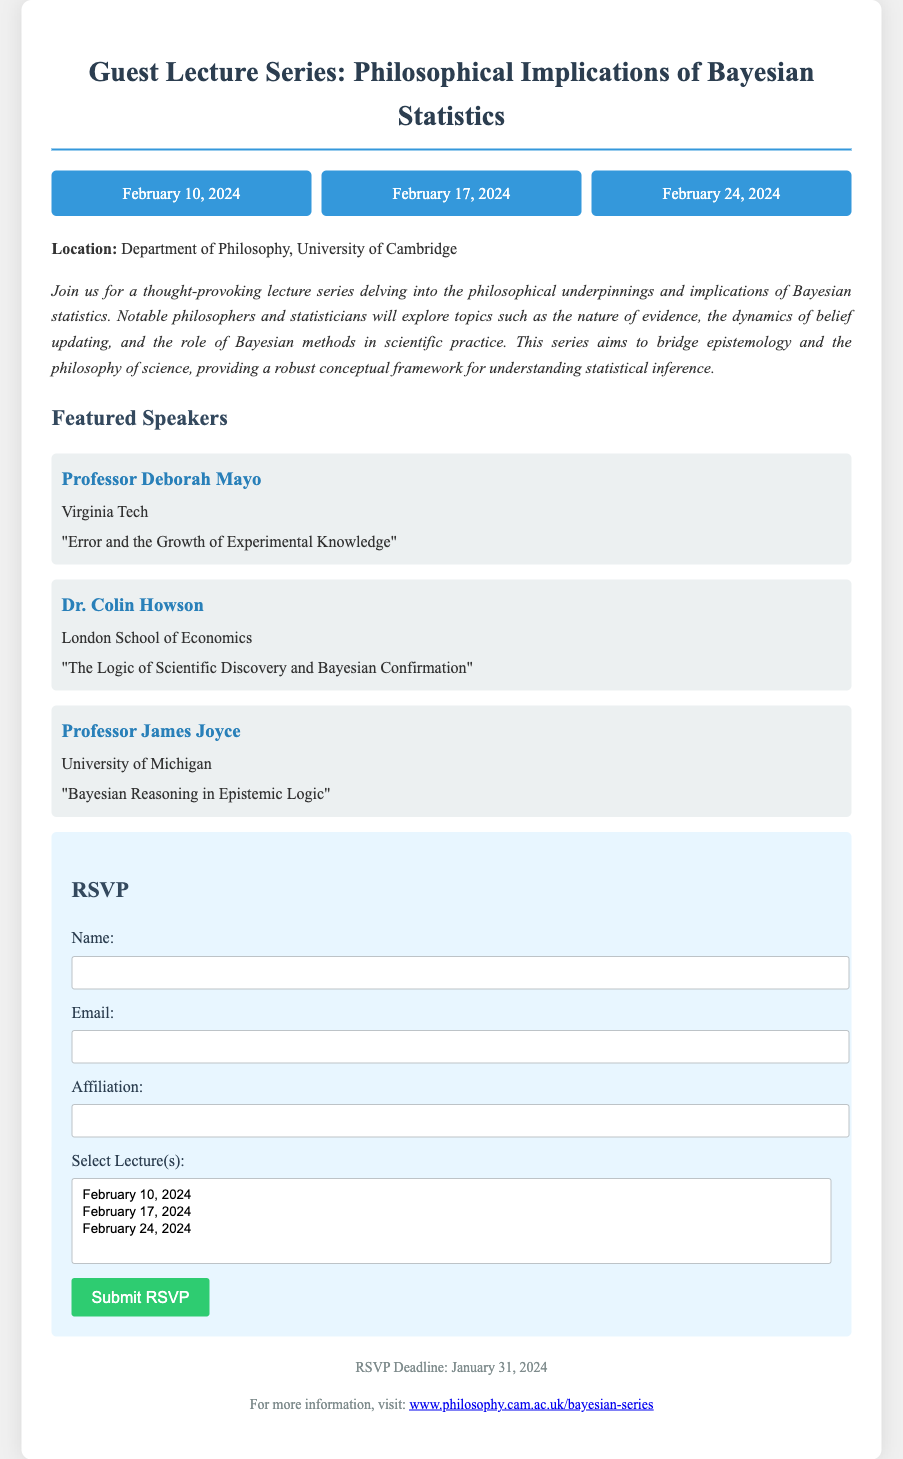What are the dates of the lectures? The document lists three specific dates for the lectures: February 10, 2024; February 17, 2024; and February 24, 2024.
Answer: February 10, 2024; February 17, 2024; February 24, 2024 Who is the speaker for the lecture on "Error and the Growth of Experimental Knowledge"? The document provides the name of the speaker associated with that lecture title, which is Professor Deborah Mayo.
Answer: Professor Deborah Mayo What is the RSVP deadline? The document specifies the final date by which guests must RSVP as January 31, 2024.
Answer: January 31, 2024 How many lecturers are featured in the series? By counting the listed speakers in the document, there are three featured speakers for the lecture series.
Answer: Three What is the location of the event? The document explicitly states the venue for the lectures, which is the Department of Philosophy, University of Cambridge.
Answer: Department of Philosophy, University of Cambridge What topic does Dr. Colin Howson speak on? The document includes the specific title of Dr. Colin Howson's talk, which is "The Logic of Scientific Discovery and Bayesian Confirmation."
Answer: The Logic of Scientific Discovery and Bayesian Confirmation Which lecture can attendees select on February 24, 2024? The document indicates that February 24, 2024, is one of the dates available for selection and indicates guests can choose that date when RSVPing.
Answer: February 24, 2024 What is the primary theme of the lecture series? The document summarizes the main focus of the series, which is on the philosophical implications of Bayesian statistics.
Answer: Philosophical implications of Bayesian statistics 